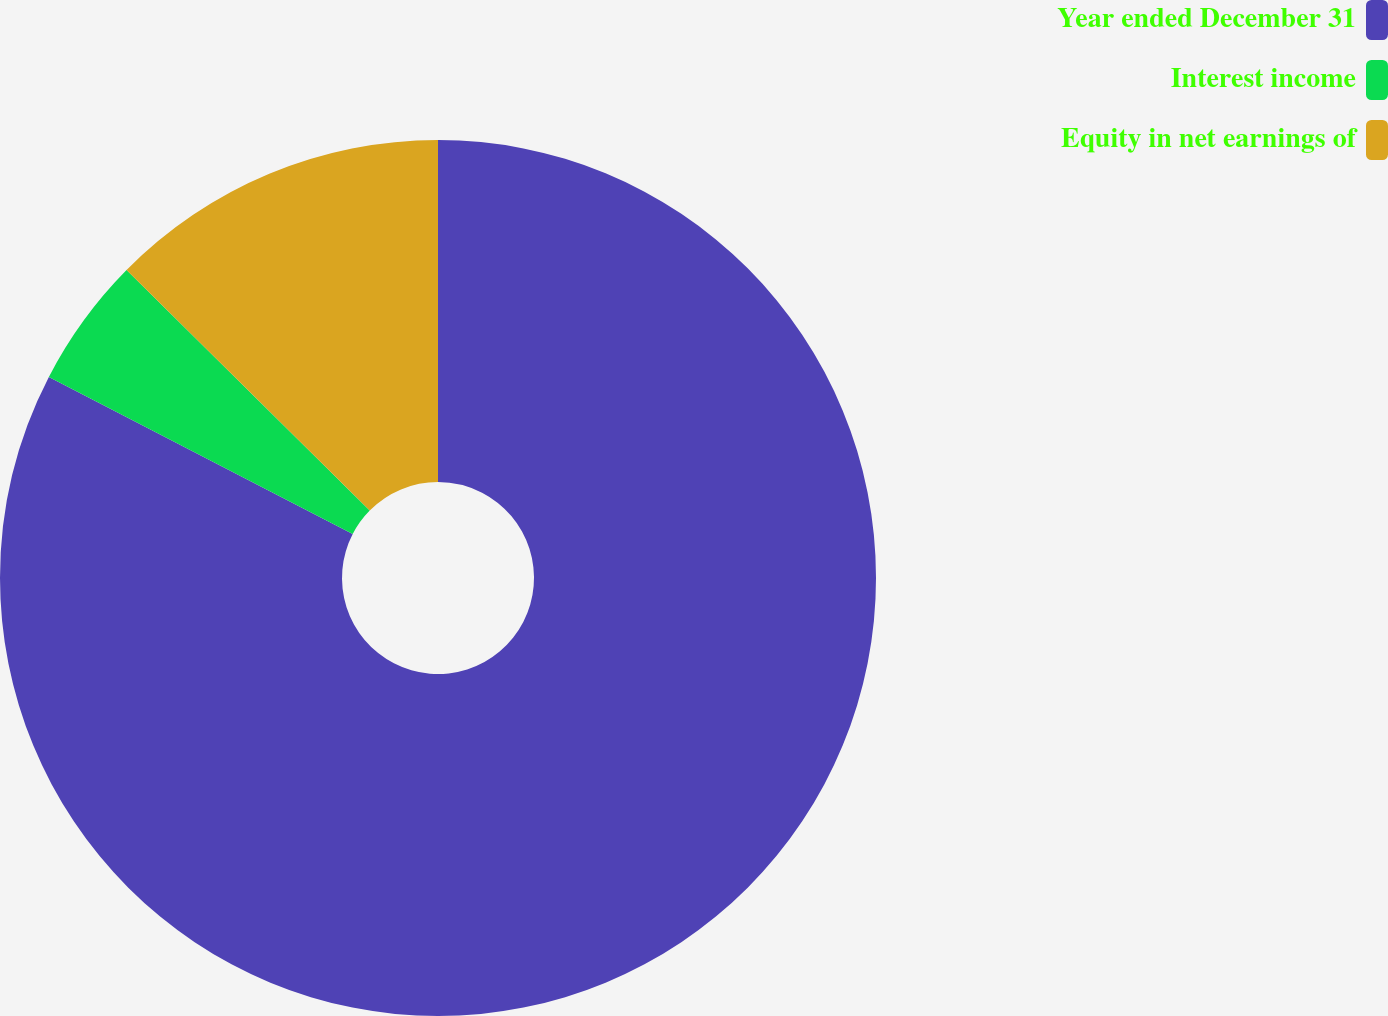Convert chart to OTSL. <chart><loc_0><loc_0><loc_500><loc_500><pie_chart><fcel>Year ended December 31<fcel>Interest income<fcel>Equity in net earnings of<nl><fcel>82.59%<fcel>4.82%<fcel>12.59%<nl></chart> 